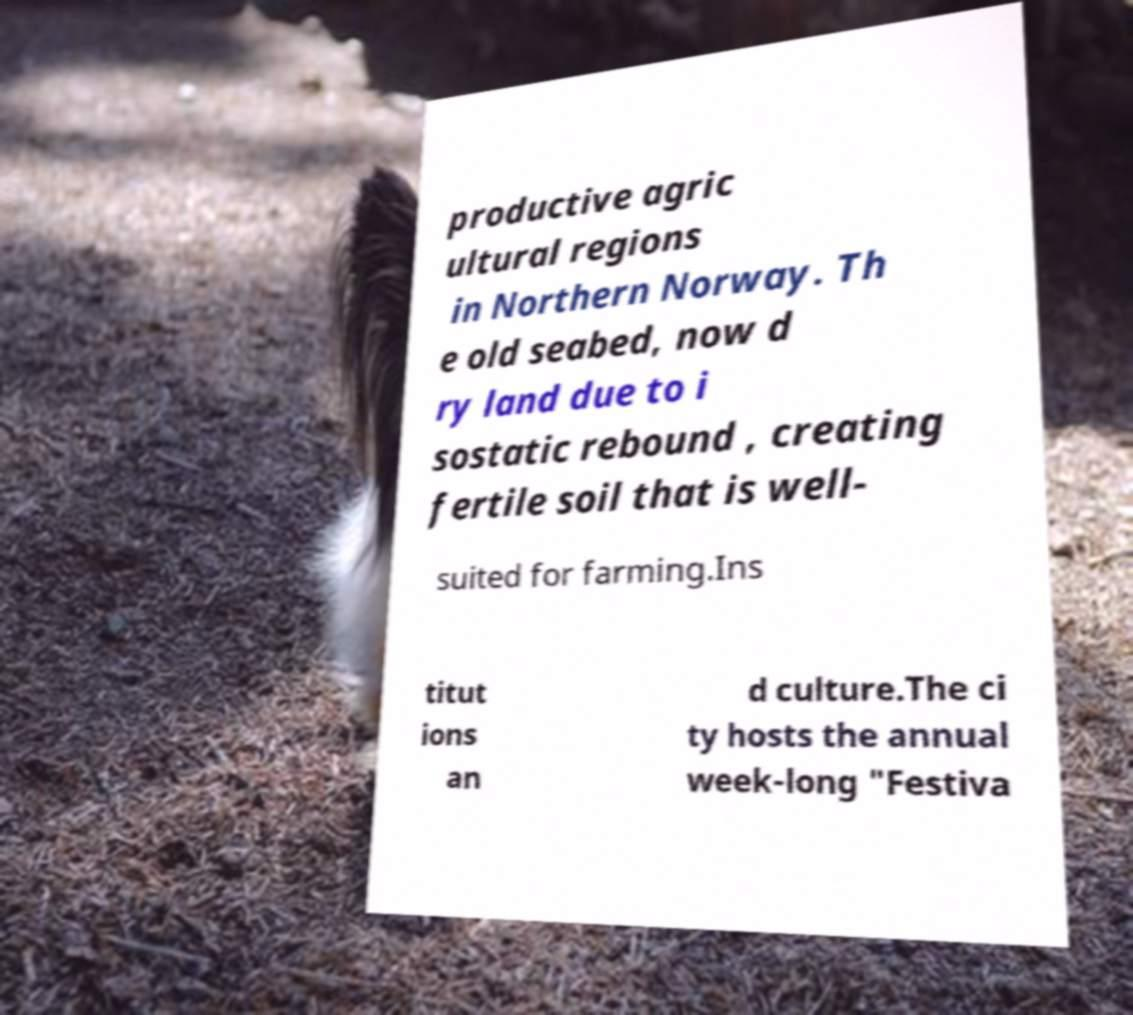What messages or text are displayed in this image? I need them in a readable, typed format. productive agric ultural regions in Northern Norway. Th e old seabed, now d ry land due to i sostatic rebound , creating fertile soil that is well- suited for farming.Ins titut ions an d culture.The ci ty hosts the annual week-long "Festiva 